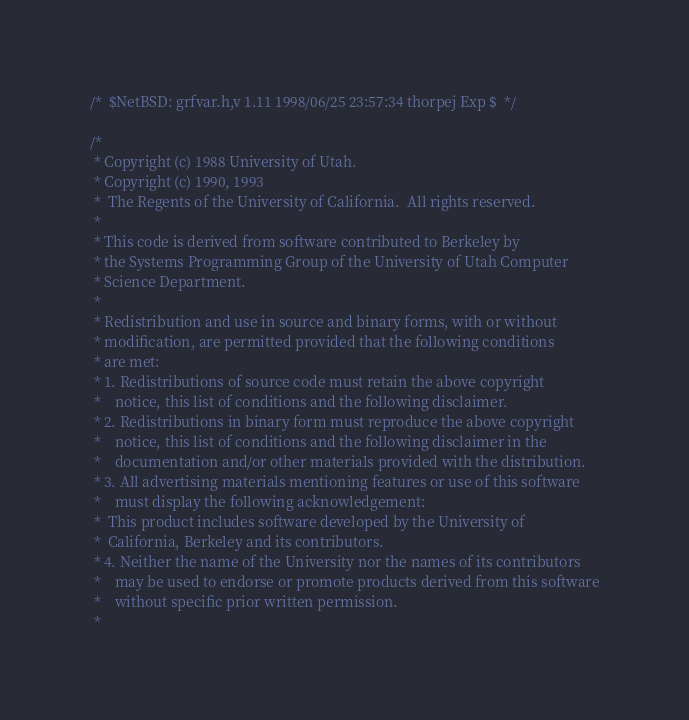Convert code to text. <code><loc_0><loc_0><loc_500><loc_500><_C_>/*	$NetBSD: grfvar.h,v 1.11 1998/06/25 23:57:34 thorpej Exp $	*/

/*
 * Copyright (c) 1988 University of Utah.
 * Copyright (c) 1990, 1993
 *	The Regents of the University of California.  All rights reserved.
 *
 * This code is derived from software contributed to Berkeley by
 * the Systems Programming Group of the University of Utah Computer
 * Science Department.
 *
 * Redistribution and use in source and binary forms, with or without
 * modification, are permitted provided that the following conditions
 * are met:
 * 1. Redistributions of source code must retain the above copyright
 *    notice, this list of conditions and the following disclaimer.
 * 2. Redistributions in binary form must reproduce the above copyright
 *    notice, this list of conditions and the following disclaimer in the
 *    documentation and/or other materials provided with the distribution.
 * 3. All advertising materials mentioning features or use of this software
 *    must display the following acknowledgement:
 *	This product includes software developed by the University of
 *	California, Berkeley and its contributors.
 * 4. Neither the name of the University nor the names of its contributors
 *    may be used to endorse or promote products derived from this software
 *    without specific prior written permission.
 *</code> 